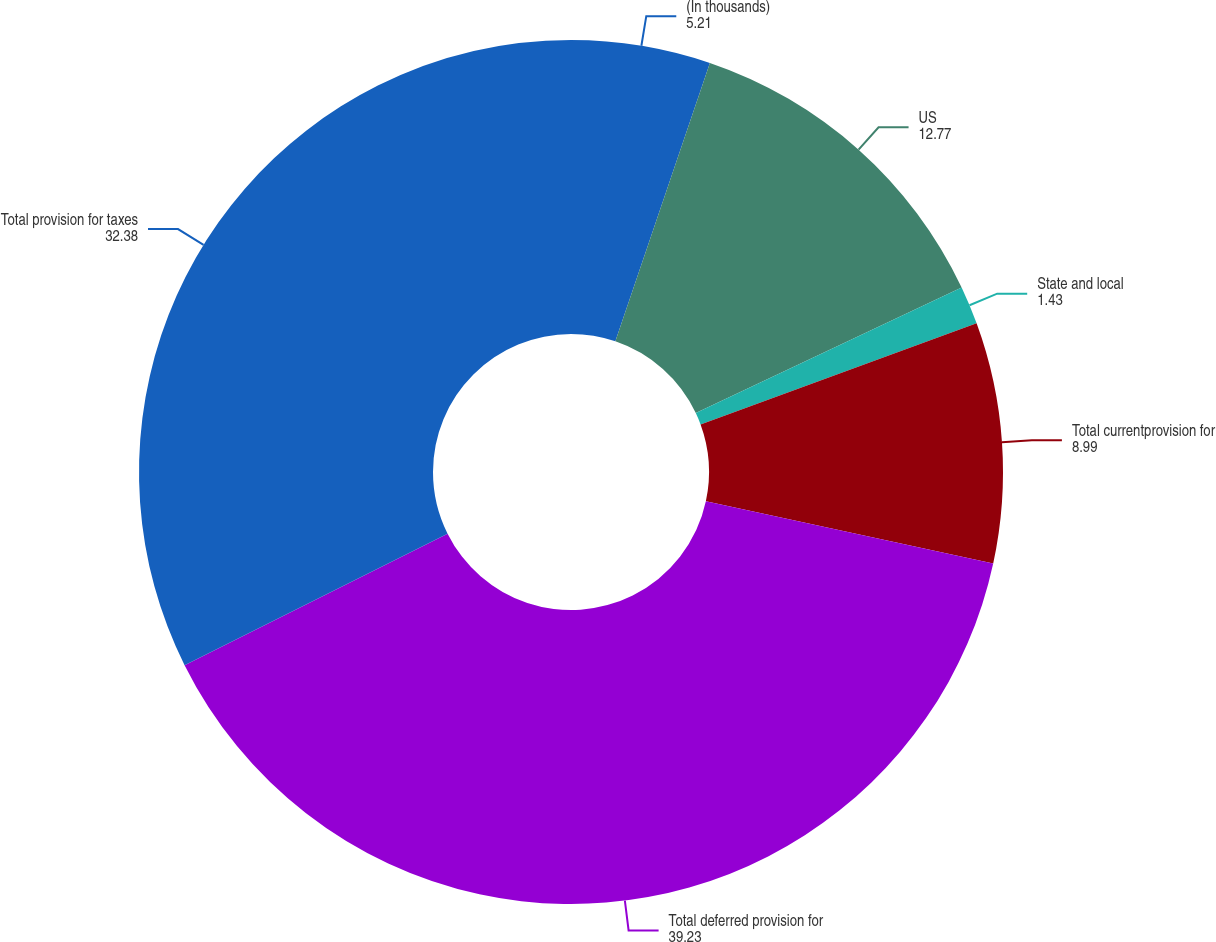Convert chart to OTSL. <chart><loc_0><loc_0><loc_500><loc_500><pie_chart><fcel>(In thousands)<fcel>US<fcel>State and local<fcel>Total currentprovision for<fcel>Total deferred provision for<fcel>Total provision for taxes<nl><fcel>5.21%<fcel>12.77%<fcel>1.43%<fcel>8.99%<fcel>39.23%<fcel>32.38%<nl></chart> 